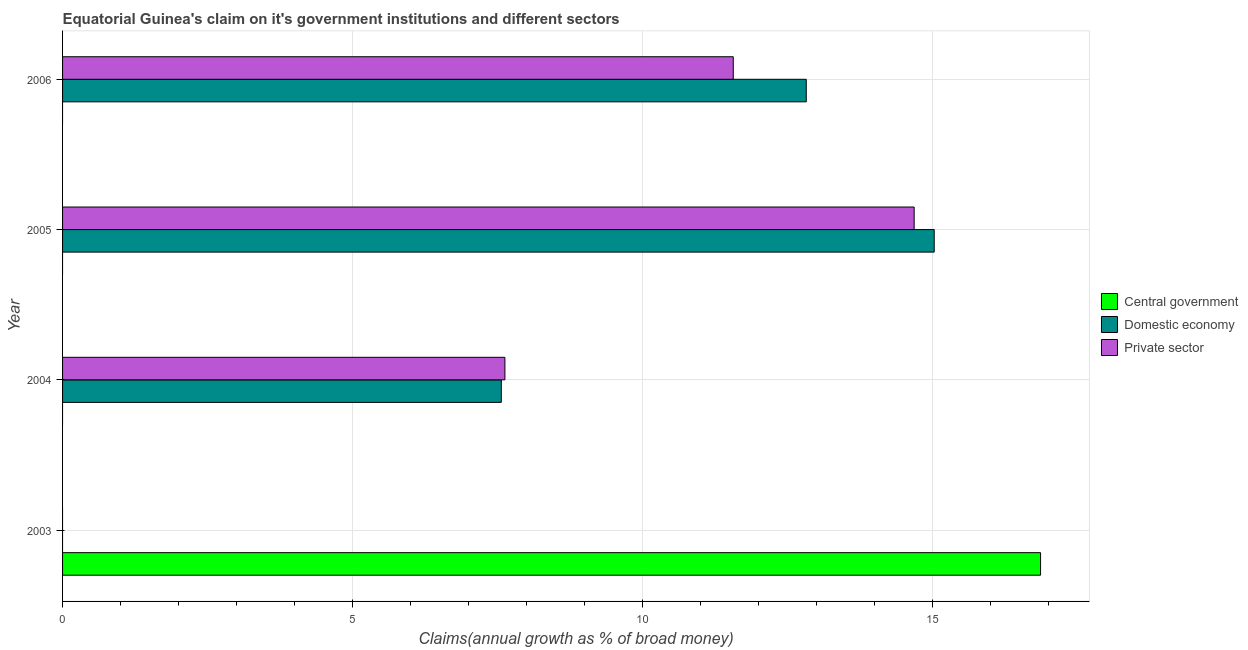How many different coloured bars are there?
Give a very brief answer. 3. Are the number of bars on each tick of the Y-axis equal?
Ensure brevity in your answer.  No. In how many cases, is the number of bars for a given year not equal to the number of legend labels?
Offer a terse response. 4. What is the percentage of claim on the domestic economy in 2006?
Your answer should be very brief. 12.82. Across all years, what is the maximum percentage of claim on the private sector?
Offer a terse response. 14.68. What is the total percentage of claim on the private sector in the graph?
Provide a succinct answer. 33.87. What is the difference between the percentage of claim on the domestic economy in 2004 and that in 2006?
Your answer should be compact. -5.26. What is the difference between the percentage of claim on the private sector in 2004 and the percentage of claim on the central government in 2003?
Keep it short and to the point. -9.24. What is the average percentage of claim on the domestic economy per year?
Make the answer very short. 8.85. In the year 2005, what is the difference between the percentage of claim on the domestic economy and percentage of claim on the private sector?
Give a very brief answer. 0.35. In how many years, is the percentage of claim on the domestic economy greater than 7 %?
Offer a terse response. 3. What is the ratio of the percentage of claim on the private sector in 2005 to that in 2006?
Provide a short and direct response. 1.27. What is the difference between the highest and the second highest percentage of claim on the domestic economy?
Your answer should be very brief. 2.21. What is the difference between the highest and the lowest percentage of claim on the private sector?
Offer a very short reply. 14.68. In how many years, is the percentage of claim on the domestic economy greater than the average percentage of claim on the domestic economy taken over all years?
Offer a terse response. 2. Is the sum of the percentage of claim on the private sector in 2005 and 2006 greater than the maximum percentage of claim on the central government across all years?
Your answer should be compact. Yes. Is it the case that in every year, the sum of the percentage of claim on the central government and percentage of claim on the domestic economy is greater than the percentage of claim on the private sector?
Your answer should be compact. No. How many years are there in the graph?
Make the answer very short. 4. What is the difference between two consecutive major ticks on the X-axis?
Give a very brief answer. 5. Does the graph contain any zero values?
Provide a short and direct response. Yes. Where does the legend appear in the graph?
Offer a terse response. Center right. What is the title of the graph?
Make the answer very short. Equatorial Guinea's claim on it's government institutions and different sectors. What is the label or title of the X-axis?
Provide a succinct answer. Claims(annual growth as % of broad money). What is the Claims(annual growth as % of broad money) of Central government in 2003?
Keep it short and to the point. 16.86. What is the Claims(annual growth as % of broad money) in Domestic economy in 2003?
Keep it short and to the point. 0. What is the Claims(annual growth as % of broad money) of Central government in 2004?
Offer a terse response. 0. What is the Claims(annual growth as % of broad money) of Domestic economy in 2004?
Your response must be concise. 7.56. What is the Claims(annual growth as % of broad money) of Private sector in 2004?
Offer a terse response. 7.63. What is the Claims(annual growth as % of broad money) of Central government in 2005?
Provide a succinct answer. 0. What is the Claims(annual growth as % of broad money) of Domestic economy in 2005?
Offer a very short reply. 15.03. What is the Claims(annual growth as % of broad money) of Private sector in 2005?
Provide a short and direct response. 14.68. What is the Claims(annual growth as % of broad money) in Central government in 2006?
Offer a very short reply. 0. What is the Claims(annual growth as % of broad money) in Domestic economy in 2006?
Keep it short and to the point. 12.82. What is the Claims(annual growth as % of broad money) of Private sector in 2006?
Make the answer very short. 11.56. Across all years, what is the maximum Claims(annual growth as % of broad money) in Central government?
Make the answer very short. 16.86. Across all years, what is the maximum Claims(annual growth as % of broad money) of Domestic economy?
Your answer should be very brief. 15.03. Across all years, what is the maximum Claims(annual growth as % of broad money) of Private sector?
Keep it short and to the point. 14.68. Across all years, what is the minimum Claims(annual growth as % of broad money) of Central government?
Provide a succinct answer. 0. Across all years, what is the minimum Claims(annual growth as % of broad money) of Private sector?
Make the answer very short. 0. What is the total Claims(annual growth as % of broad money) of Central government in the graph?
Offer a terse response. 16.86. What is the total Claims(annual growth as % of broad money) of Domestic economy in the graph?
Give a very brief answer. 35.42. What is the total Claims(annual growth as % of broad money) of Private sector in the graph?
Make the answer very short. 33.87. What is the difference between the Claims(annual growth as % of broad money) in Domestic economy in 2004 and that in 2005?
Offer a terse response. -7.46. What is the difference between the Claims(annual growth as % of broad money) of Private sector in 2004 and that in 2005?
Your answer should be very brief. -7.06. What is the difference between the Claims(annual growth as % of broad money) in Domestic economy in 2004 and that in 2006?
Make the answer very short. -5.26. What is the difference between the Claims(annual growth as % of broad money) in Private sector in 2004 and that in 2006?
Keep it short and to the point. -3.94. What is the difference between the Claims(annual growth as % of broad money) in Domestic economy in 2005 and that in 2006?
Your answer should be compact. 2.21. What is the difference between the Claims(annual growth as % of broad money) in Private sector in 2005 and that in 2006?
Offer a very short reply. 3.12. What is the difference between the Claims(annual growth as % of broad money) of Central government in 2003 and the Claims(annual growth as % of broad money) of Domestic economy in 2004?
Offer a terse response. 9.3. What is the difference between the Claims(annual growth as % of broad money) of Central government in 2003 and the Claims(annual growth as % of broad money) of Private sector in 2004?
Ensure brevity in your answer.  9.24. What is the difference between the Claims(annual growth as % of broad money) of Central government in 2003 and the Claims(annual growth as % of broad money) of Domestic economy in 2005?
Ensure brevity in your answer.  1.83. What is the difference between the Claims(annual growth as % of broad money) in Central government in 2003 and the Claims(annual growth as % of broad money) in Private sector in 2005?
Provide a succinct answer. 2.18. What is the difference between the Claims(annual growth as % of broad money) in Central government in 2003 and the Claims(annual growth as % of broad money) in Domestic economy in 2006?
Offer a very short reply. 4.04. What is the difference between the Claims(annual growth as % of broad money) of Central government in 2003 and the Claims(annual growth as % of broad money) of Private sector in 2006?
Provide a succinct answer. 5.3. What is the difference between the Claims(annual growth as % of broad money) in Domestic economy in 2004 and the Claims(annual growth as % of broad money) in Private sector in 2005?
Give a very brief answer. -7.12. What is the difference between the Claims(annual growth as % of broad money) of Domestic economy in 2004 and the Claims(annual growth as % of broad money) of Private sector in 2006?
Ensure brevity in your answer.  -4. What is the difference between the Claims(annual growth as % of broad money) in Domestic economy in 2005 and the Claims(annual growth as % of broad money) in Private sector in 2006?
Ensure brevity in your answer.  3.46. What is the average Claims(annual growth as % of broad money) of Central government per year?
Provide a succinct answer. 4.22. What is the average Claims(annual growth as % of broad money) in Domestic economy per year?
Provide a short and direct response. 8.85. What is the average Claims(annual growth as % of broad money) in Private sector per year?
Offer a terse response. 8.47. In the year 2004, what is the difference between the Claims(annual growth as % of broad money) of Domestic economy and Claims(annual growth as % of broad money) of Private sector?
Your answer should be compact. -0.06. In the year 2005, what is the difference between the Claims(annual growth as % of broad money) in Domestic economy and Claims(annual growth as % of broad money) in Private sector?
Make the answer very short. 0.35. In the year 2006, what is the difference between the Claims(annual growth as % of broad money) in Domestic economy and Claims(annual growth as % of broad money) in Private sector?
Provide a succinct answer. 1.26. What is the ratio of the Claims(annual growth as % of broad money) of Domestic economy in 2004 to that in 2005?
Provide a short and direct response. 0.5. What is the ratio of the Claims(annual growth as % of broad money) in Private sector in 2004 to that in 2005?
Keep it short and to the point. 0.52. What is the ratio of the Claims(annual growth as % of broad money) of Domestic economy in 2004 to that in 2006?
Offer a terse response. 0.59. What is the ratio of the Claims(annual growth as % of broad money) of Private sector in 2004 to that in 2006?
Make the answer very short. 0.66. What is the ratio of the Claims(annual growth as % of broad money) of Domestic economy in 2005 to that in 2006?
Your answer should be compact. 1.17. What is the ratio of the Claims(annual growth as % of broad money) in Private sector in 2005 to that in 2006?
Ensure brevity in your answer.  1.27. What is the difference between the highest and the second highest Claims(annual growth as % of broad money) in Domestic economy?
Offer a very short reply. 2.21. What is the difference between the highest and the second highest Claims(annual growth as % of broad money) in Private sector?
Keep it short and to the point. 3.12. What is the difference between the highest and the lowest Claims(annual growth as % of broad money) in Central government?
Your answer should be very brief. 16.86. What is the difference between the highest and the lowest Claims(annual growth as % of broad money) in Domestic economy?
Your answer should be very brief. 15.03. What is the difference between the highest and the lowest Claims(annual growth as % of broad money) in Private sector?
Give a very brief answer. 14.68. 